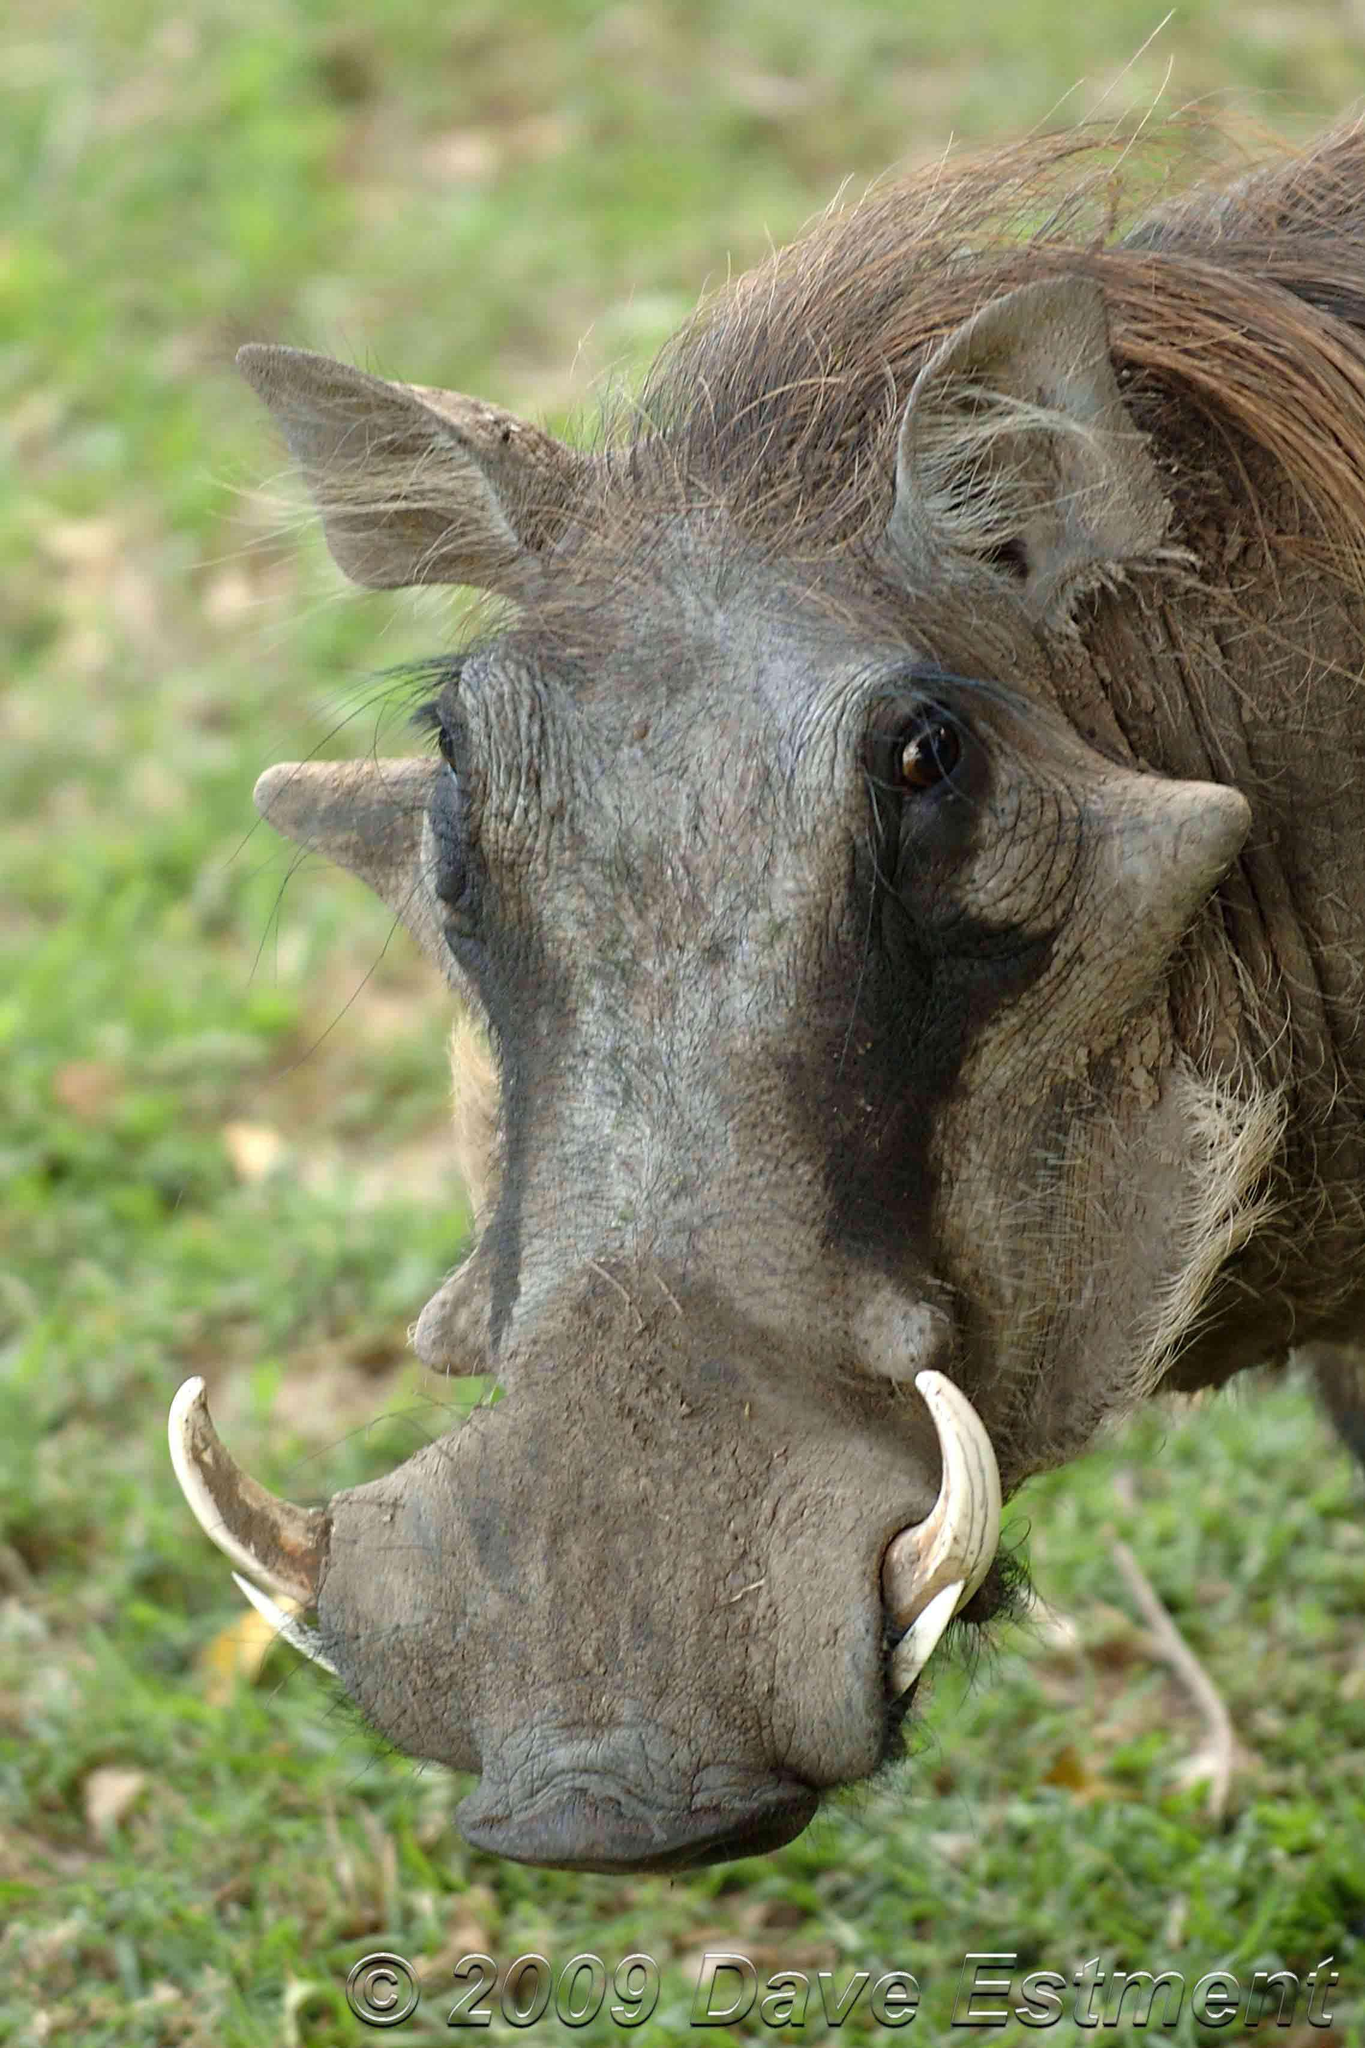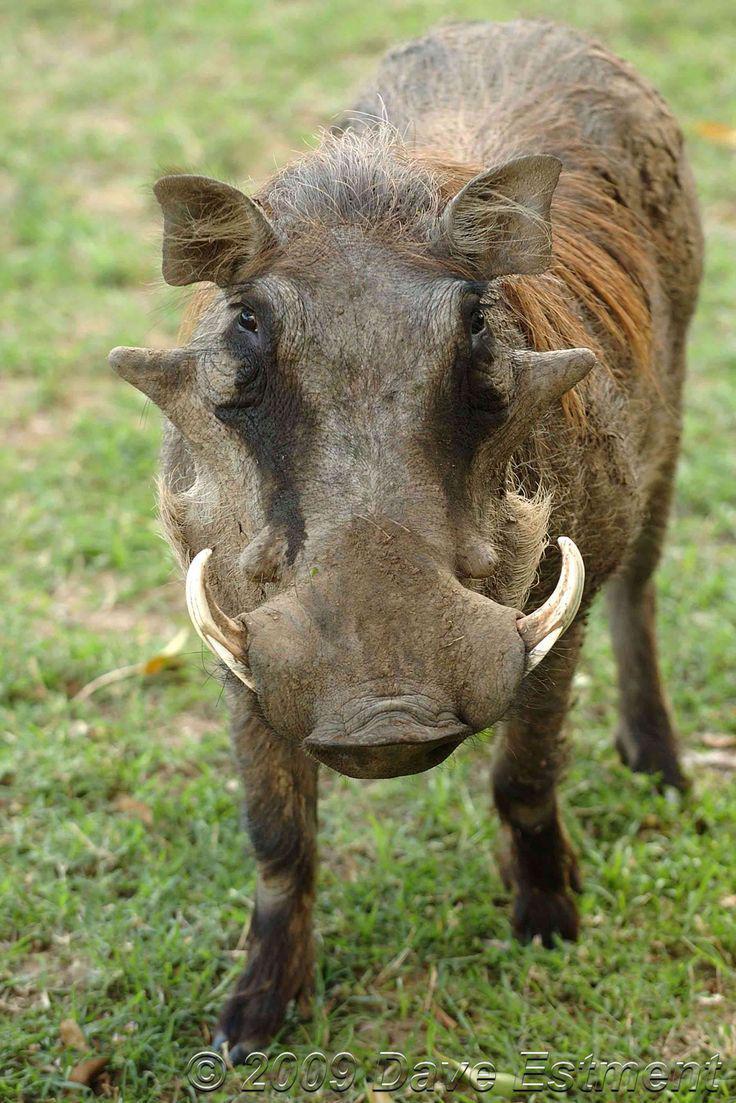The first image is the image on the left, the second image is the image on the right. Assess this claim about the two images: "More than one warthog is present in one of the images.". Correct or not? Answer yes or no. No. 